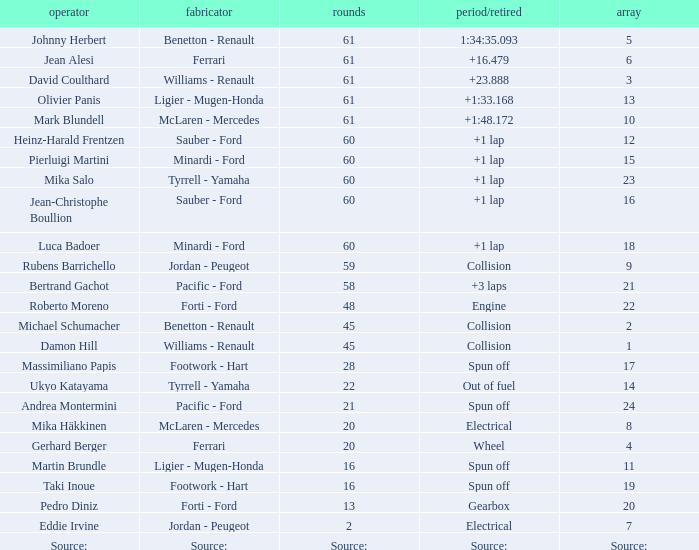What grid has 2 laps? 7.0. 